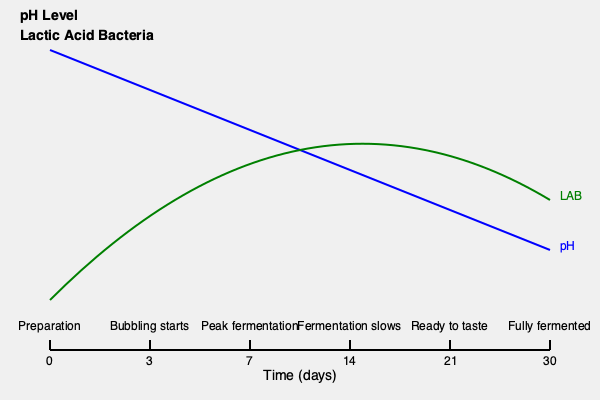Based on the timeline infographic of the Croatian pickled vegetable fermentation process, at which day does the fermentation activity reach its highest point, and what happens to the pH level and lactic acid bacteria (LAB) concentration at this stage? The fermentation process of Croatian pickled vegetables can be understood through the following steps:

1. Day 0: Preparation of vegetables and brine solution.

2. Day 3: Bubbling starts, indicating the beginning of fermentation. Lactic acid bacteria (LAB) begin to multiply, and pH starts to decrease.

3. Day 7: Peak fermentation occurs. This is the point where:
   a) LAB concentration reaches its highest level
   b) pH drops rapidly due to increased lactic acid production
   c) Fermentation activity is at its most intense

4. Day 14: Fermentation begins to slow down. LAB concentration starts to stabilize, and pH continues to decrease but at a slower rate.

5. Day 21: Pickles are ready for tasting. pH has reached a low, stable level, and LAB concentration has slightly decreased.

6. Day 30: Pickles are fully fermented. pH is at its lowest point, and LAB concentration has stabilized.

At the peak fermentation point (Day 7), the pH level is rapidly decreasing due to the high activity of lactic acid bacteria. The LAB concentration reaches its maximum, resulting in the most intense fermentation activity.
Answer: Day 7; pH rapidly decreasing, LAB concentration at maximum. 